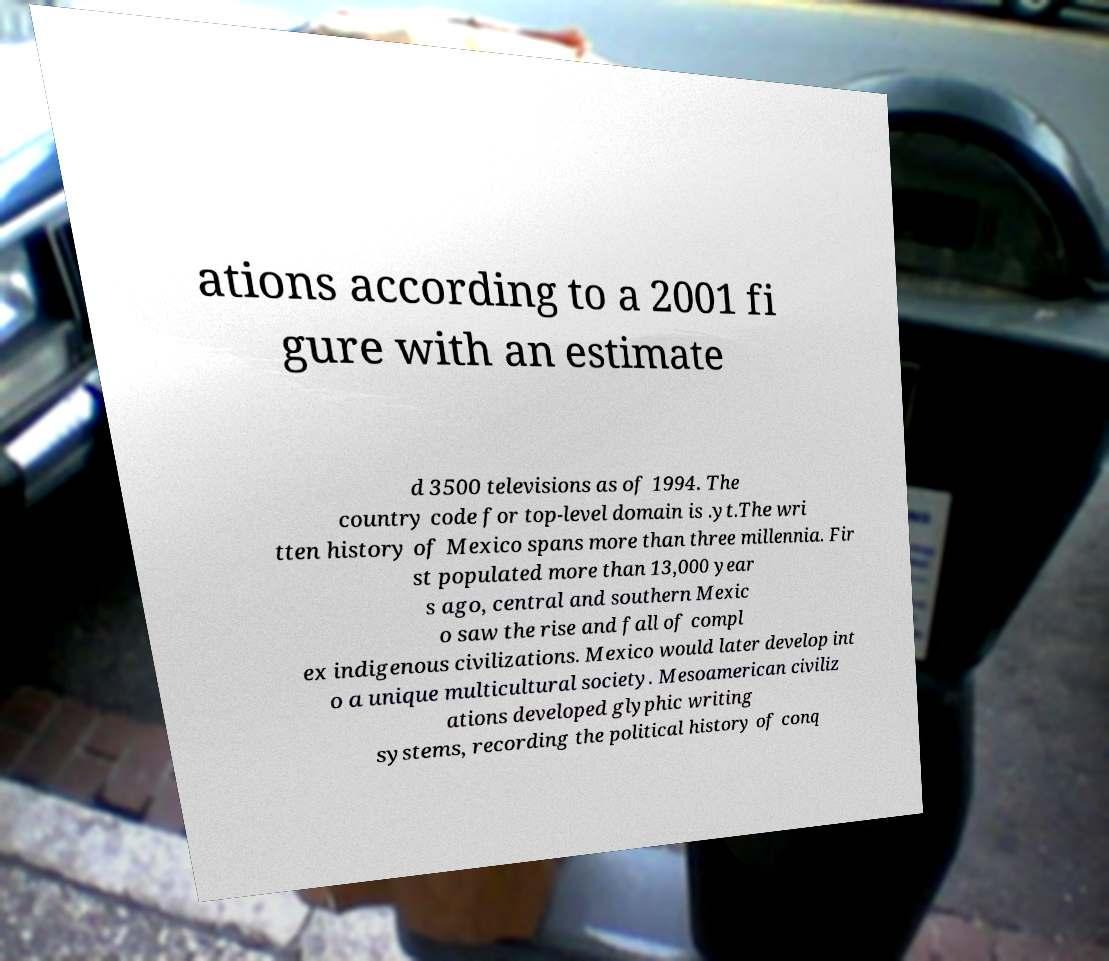Please read and relay the text visible in this image. What does it say? ations according to a 2001 fi gure with an estimate d 3500 televisions as of 1994. The country code for top-level domain is .yt.The wri tten history of Mexico spans more than three millennia. Fir st populated more than 13,000 year s ago, central and southern Mexic o saw the rise and fall of compl ex indigenous civilizations. Mexico would later develop int o a unique multicultural society. Mesoamerican civiliz ations developed glyphic writing systems, recording the political history of conq 